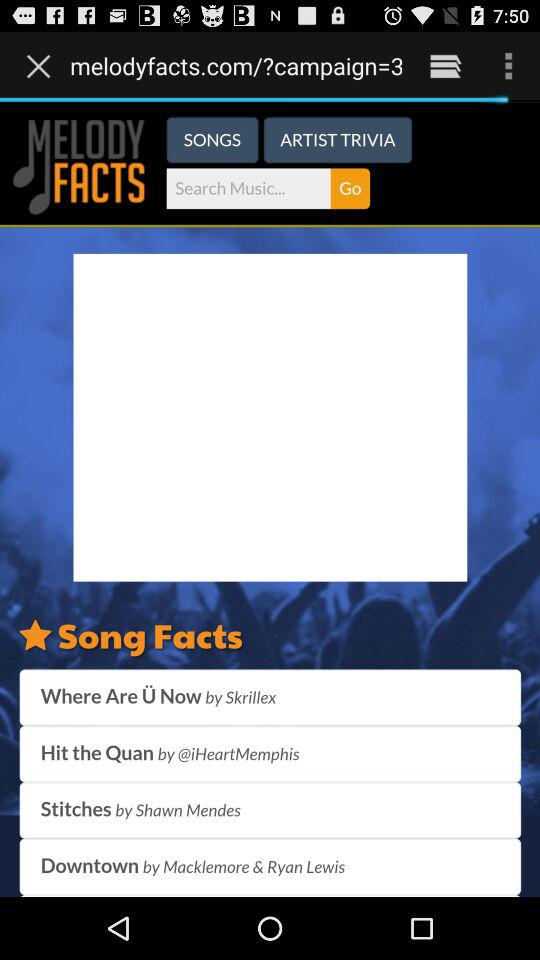Which song is sung by Shawn Mendes? The song "Stitches" is sung by Shawn Mendes. 